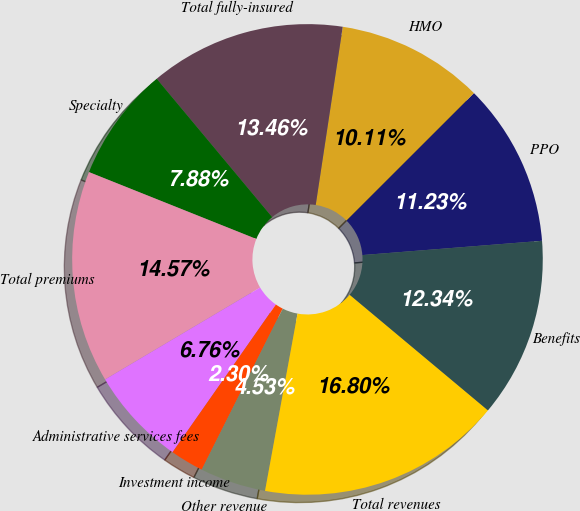Convert chart to OTSL. <chart><loc_0><loc_0><loc_500><loc_500><pie_chart><fcel>PPO<fcel>HMO<fcel>Total fully-insured<fcel>Specialty<fcel>Total premiums<fcel>Administrative services fees<fcel>Investment income<fcel>Other revenue<fcel>Total revenues<fcel>Benefits<nl><fcel>11.23%<fcel>10.11%<fcel>13.46%<fcel>7.88%<fcel>14.57%<fcel>6.76%<fcel>2.3%<fcel>4.53%<fcel>16.8%<fcel>12.34%<nl></chart> 